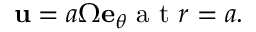<formula> <loc_0><loc_0><loc_500><loc_500>u = a \Omega e _ { \theta } a t r = a .</formula> 